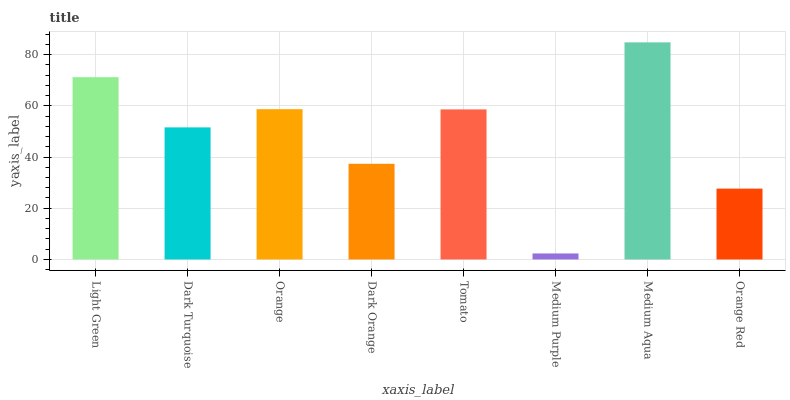Is Medium Purple the minimum?
Answer yes or no. Yes. Is Medium Aqua the maximum?
Answer yes or no. Yes. Is Dark Turquoise the minimum?
Answer yes or no. No. Is Dark Turquoise the maximum?
Answer yes or no. No. Is Light Green greater than Dark Turquoise?
Answer yes or no. Yes. Is Dark Turquoise less than Light Green?
Answer yes or no. Yes. Is Dark Turquoise greater than Light Green?
Answer yes or no. No. Is Light Green less than Dark Turquoise?
Answer yes or no. No. Is Tomato the high median?
Answer yes or no. Yes. Is Dark Turquoise the low median?
Answer yes or no. Yes. Is Medium Purple the high median?
Answer yes or no. No. Is Medium Purple the low median?
Answer yes or no. No. 